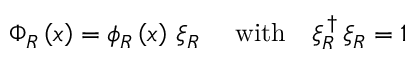<formula> <loc_0><loc_0><loc_500><loc_500>\begin{array} { r } { \Phi _ { R } \left ( x \right ) = \phi _ { R } \left ( x \right ) \, \xi _ { R } \quad \ w i t h \quad \xi _ { R } ^ { \, \dag } \, \xi _ { R } = 1 } \end{array}</formula> 